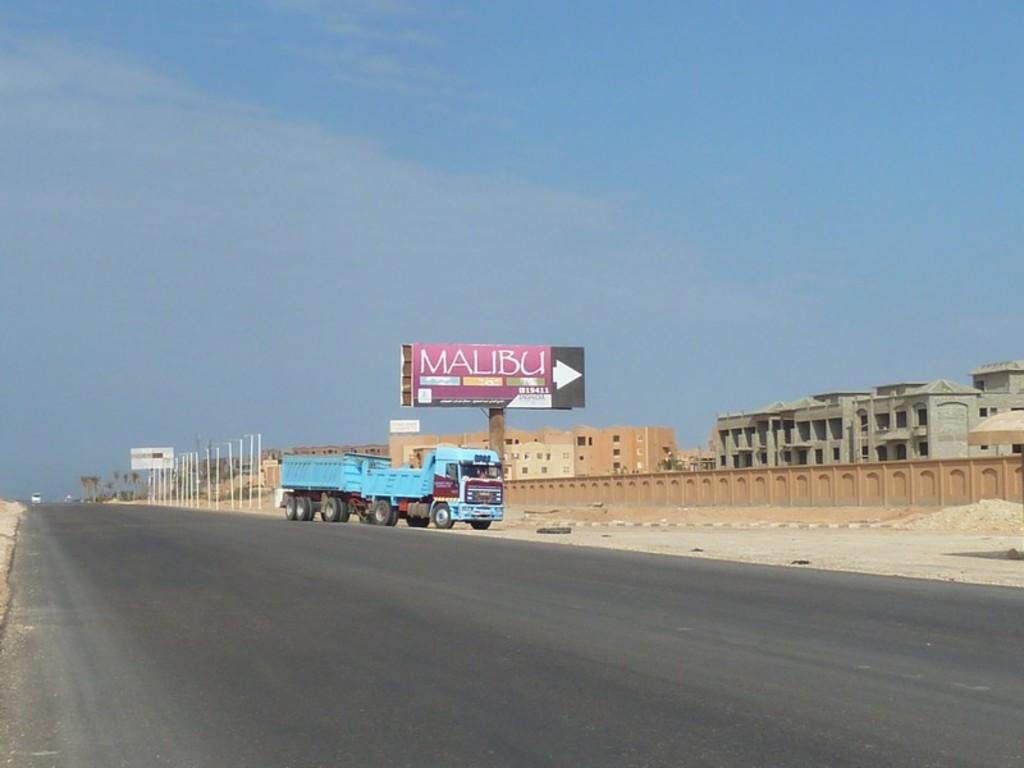<image>
Summarize the visual content of the image. A blue truck parked under a Malibu billboard sign. 